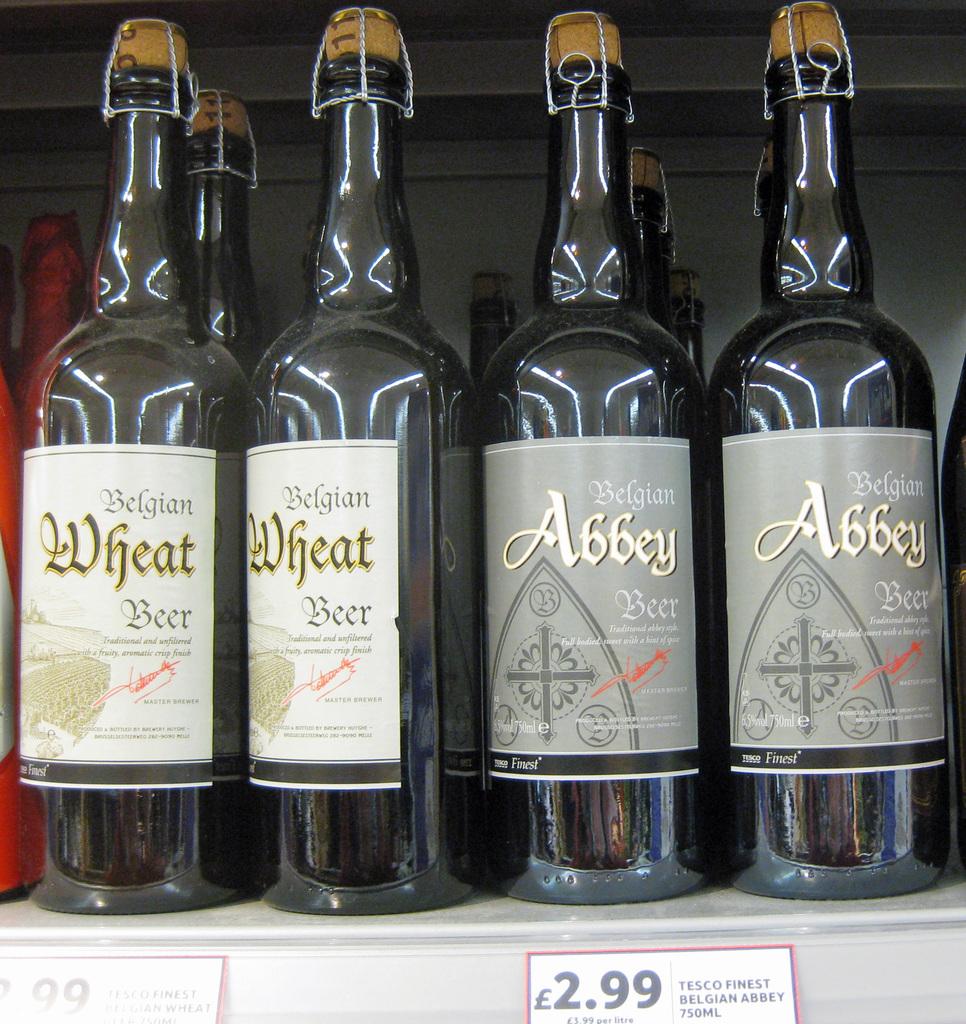What kind of drink is this?
Keep it short and to the point. Beer. What is the price of this wine?
Your response must be concise. 2.99. 